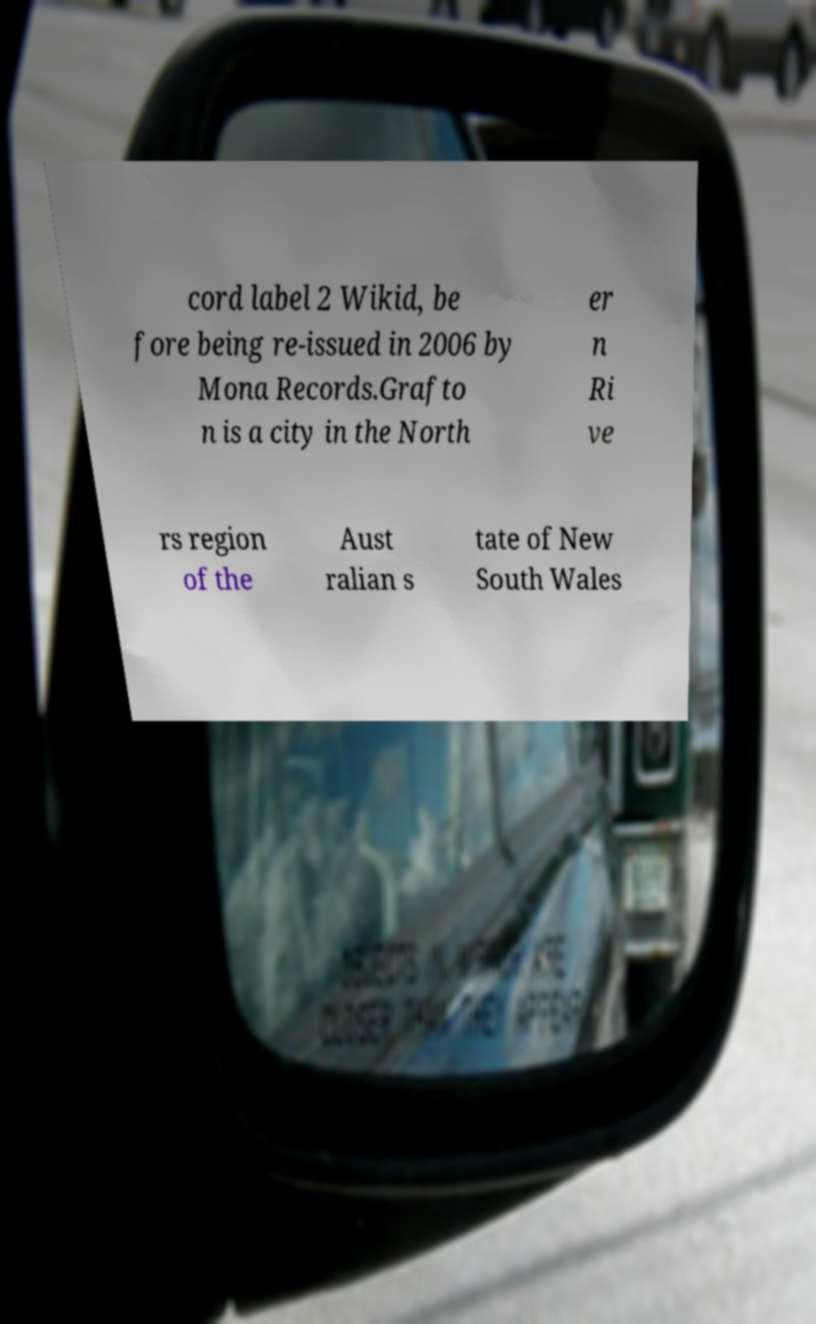Please identify and transcribe the text found in this image. cord label 2 Wikid, be fore being re-issued in 2006 by Mona Records.Grafto n is a city in the North er n Ri ve rs region of the Aust ralian s tate of New South Wales 